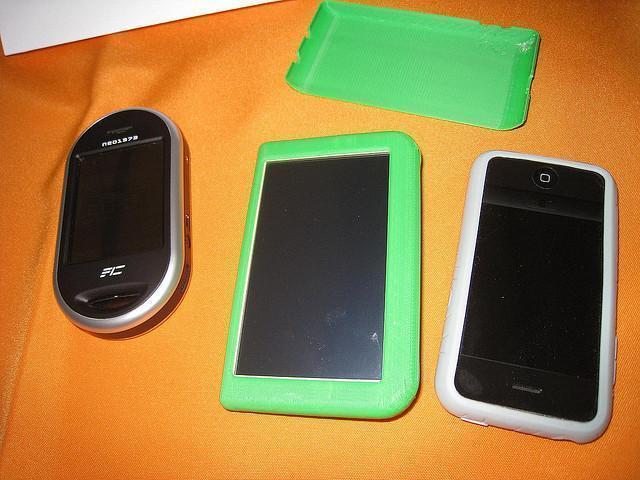What is all the way to the right?
Answer the question by selecting the correct answer among the 4 following choices and explain your choice with a short sentence. The answer should be formatted with the following format: `Answer: choice
Rationale: rationale.`
Options: Elephant, baby, phone, tiger. Answer: phone.
Rationale: The right is the phone. 